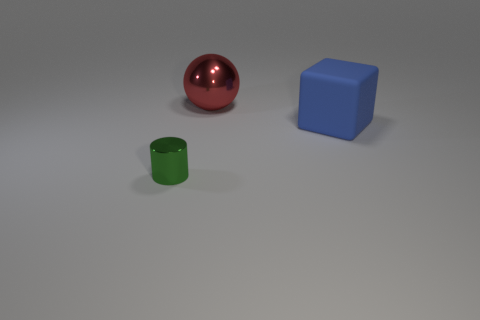Is the shape of the small thing the same as the red object?
Your response must be concise. No. There is a thing that is left of the metallic object that is to the right of the shiny object that is in front of the large blue matte thing; what size is it?
Your response must be concise. Small. How many other objects are the same material as the large red object?
Offer a terse response. 1. What is the color of the shiny object that is behind the blue rubber block?
Offer a terse response. Red. There is a large object right of the metal thing to the right of the metal thing in front of the blue block; what is its material?
Give a very brief answer. Rubber. Are there any other tiny green things of the same shape as the green thing?
Your answer should be very brief. No. What shape is the red shiny thing that is the same size as the blue cube?
Ensure brevity in your answer.  Sphere. What number of objects are behind the tiny green shiny cylinder and to the left of the large red thing?
Offer a very short reply. 0. Are there fewer blue rubber blocks in front of the blue thing than red shiny spheres?
Keep it short and to the point. Yes. Are there any red shiny blocks of the same size as the blue object?
Make the answer very short. No. 